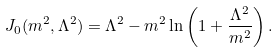<formula> <loc_0><loc_0><loc_500><loc_500>J _ { 0 } ( m ^ { 2 } , \Lambda ^ { 2 } ) = \Lambda ^ { 2 } - m ^ { 2 } \ln \left ( 1 + \frac { \Lambda ^ { 2 } } { m ^ { 2 } } \right ) .</formula> 